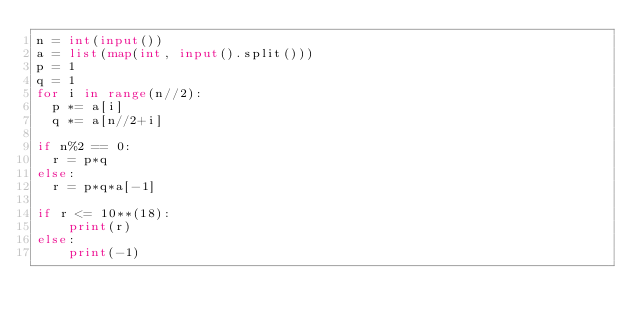<code> <loc_0><loc_0><loc_500><loc_500><_Python_>n = int(input())
a = list(map(int, input().split()))
p = 1
q = 1
for i in range(n//2):
  p *= a[i]
  q *= a[n//2+i] 

if n%2 == 0:
  r = p*q
else:
  r = p*q*a[-1]  
  
if r <= 10**(18):
    print(r)
else:
    print(-1)</code> 